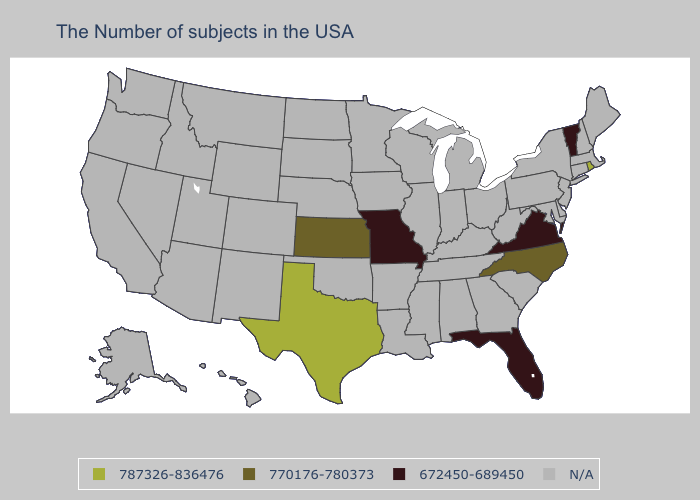What is the value of Louisiana?
Be succinct. N/A. Which states have the highest value in the USA?
Keep it brief. Rhode Island, Texas. Which states have the lowest value in the USA?
Be succinct. Vermont, Virginia, Florida, Missouri. Which states have the highest value in the USA?
Be succinct. Rhode Island, Texas. Which states have the lowest value in the MidWest?
Keep it brief. Missouri. Which states have the highest value in the USA?
Answer briefly. Rhode Island, Texas. Name the states that have a value in the range 770176-780373?
Short answer required. North Carolina, Kansas. What is the value of Louisiana?
Be succinct. N/A. What is the highest value in the USA?
Quick response, please. 787326-836476. What is the lowest value in the MidWest?
Give a very brief answer. 672450-689450. Name the states that have a value in the range N/A?
Keep it brief. Maine, Massachusetts, New Hampshire, Connecticut, New York, New Jersey, Delaware, Maryland, Pennsylvania, South Carolina, West Virginia, Ohio, Georgia, Michigan, Kentucky, Indiana, Alabama, Tennessee, Wisconsin, Illinois, Mississippi, Louisiana, Arkansas, Minnesota, Iowa, Nebraska, Oklahoma, South Dakota, North Dakota, Wyoming, Colorado, New Mexico, Utah, Montana, Arizona, Idaho, Nevada, California, Washington, Oregon, Alaska, Hawaii. Does the first symbol in the legend represent the smallest category?
Be succinct. No. 